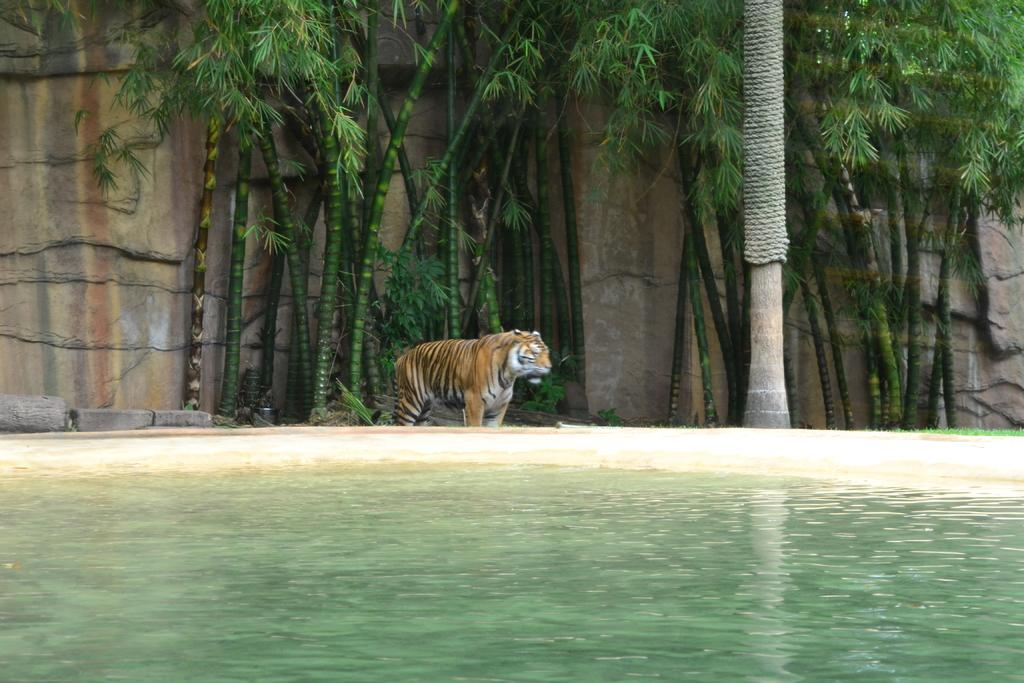What animal is standing on the ground in the image? There is a tiger standing on the ground in the image. What can be seen in the image besides the tiger? Water is visible in the image, as well as trees and a wall in the background. What type of drum is the tiger playing in the image? There is no drum present in the image; the tiger is simply standing on the ground. 